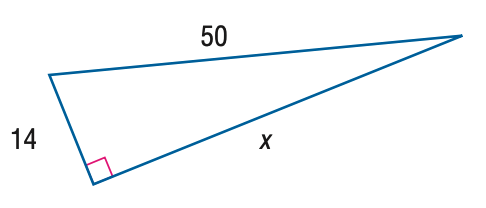Answer the mathemtical geometry problem and directly provide the correct option letter.
Question: Find x.
Choices: A: 42 B: 44 C: 46 D: 48 D 